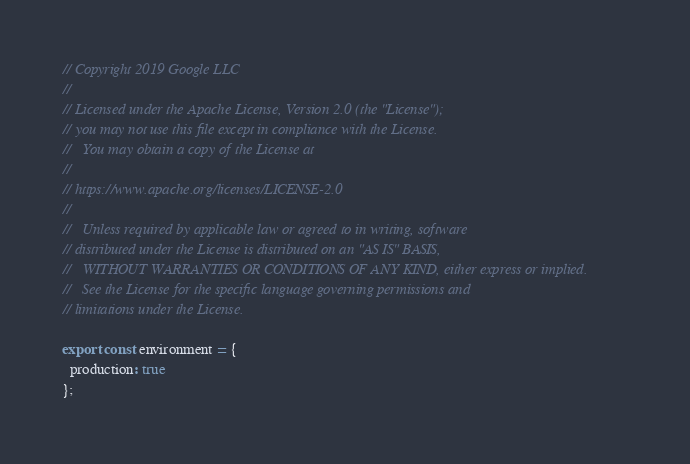<code> <loc_0><loc_0><loc_500><loc_500><_TypeScript_>// Copyright 2019 Google LLC
//
// Licensed under the Apache License, Version 2.0 (the "License");
// you may not use this file except in compliance with the License.
//   You may obtain a copy of the License at
//
// https://www.apache.org/licenses/LICENSE-2.0
//
//   Unless required by applicable law or agreed to in writing, software
// distributed under the License is distributed on an "AS IS" BASIS,
//   WITHOUT WARRANTIES OR CONDITIONS OF ANY KIND, either express or implied.
//   See the License for the specific language governing permissions and
// limitations under the License.

export const environment = {
  production: true
};
</code> 